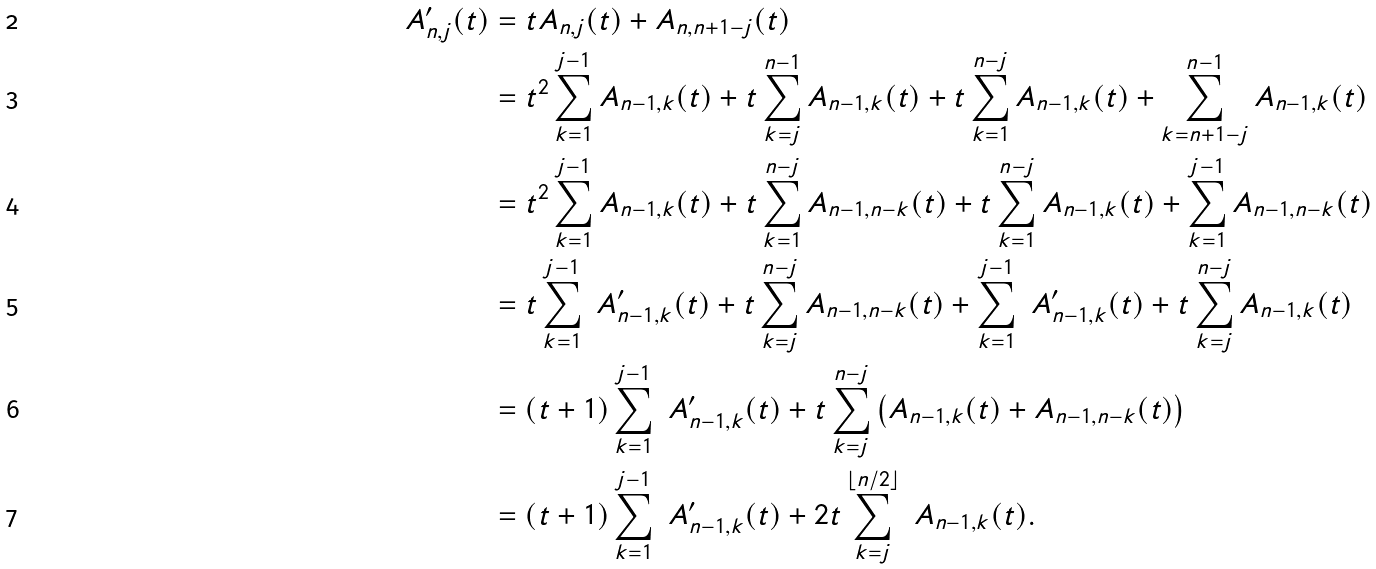<formula> <loc_0><loc_0><loc_500><loc_500>\ A ^ { \prime } _ { n , j } ( t ) & = t A _ { n , j } ( t ) + A _ { n , n + 1 - j } ( t ) \\ & = t ^ { 2 } \sum _ { k = 1 } ^ { j - 1 } A _ { n - 1 , k } ( t ) + t \sum _ { k = j } ^ { n - 1 } A _ { n - 1 , k } ( t ) + t \sum _ { k = 1 } ^ { n - j } A _ { n - 1 , k } ( t ) + \sum _ { k = n + 1 - j } ^ { n - 1 } A _ { n - 1 , k } ( t ) \\ & = t ^ { 2 } \sum _ { k = 1 } ^ { j - 1 } A _ { n - 1 , k } ( t ) + t \sum _ { k = 1 } ^ { n - j } A _ { n - 1 , n - k } ( t ) + t \sum _ { k = 1 } ^ { n - j } A _ { n - 1 , k } ( t ) + \sum _ { k = 1 } ^ { j - 1 } A _ { n - 1 , n - k } ( t ) \\ & = t \sum _ { k = 1 } ^ { j - 1 } \ A ^ { \prime } _ { n - 1 , k } ( t ) + t \sum _ { k = j } ^ { n - j } A _ { n - 1 , n - k } ( t ) + \sum _ { k = 1 } ^ { j - 1 } \ A ^ { \prime } _ { n - 1 , k } ( t ) + t \sum _ { k = j } ^ { n - j } A _ { n - 1 , k } ( t ) \\ & = ( t + 1 ) \sum _ { k = 1 } ^ { j - 1 } \ A ^ { \prime } _ { n - 1 , k } ( t ) + t \sum _ { k = j } ^ { n - j } \left ( A _ { n - 1 , k } ( t ) + A _ { n - 1 , n - k } ( t ) \right ) \\ & = ( t + 1 ) \sum _ { k = 1 } ^ { j - 1 } \ A ^ { \prime } _ { n - 1 , k } ( t ) + 2 t \sum _ { k = j } ^ { \lfloor n / 2 \rfloor } \ A _ { n - 1 , k } ( t ) .</formula> 